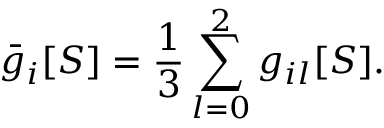Convert formula to latex. <formula><loc_0><loc_0><loc_500><loc_500>\bar { g } _ { i } [ S ] = \frac { 1 } { 3 } \sum _ { l = 0 } ^ { 2 } g _ { i l } [ S ] .</formula> 